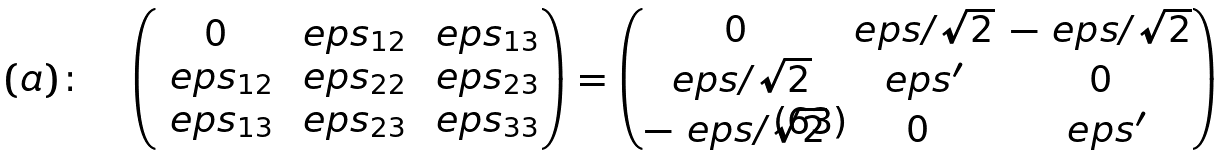Convert formula to latex. <formula><loc_0><loc_0><loc_500><loc_500>( a ) \colon \quad \begin{pmatrix} 0 & \ e p s _ { 1 2 } & \ e p s _ { 1 3 } \\ \ e p s _ { 1 2 } & \ e p s _ { 2 2 } & \ e p s _ { 2 3 } \\ \ e p s _ { 1 3 } & \ e p s _ { 2 3 } & \ e p s _ { 3 3 } \end{pmatrix} = \begin{pmatrix} 0 & \ e p s / \sqrt { 2 } & - \ e p s / \sqrt { 2 } \\ \ e p s / \sqrt { 2 } & \ e p s ^ { \prime } & 0 \\ - \ e p s / \sqrt { 2 } & 0 & \ e p s ^ { \prime } \end{pmatrix}</formula> 